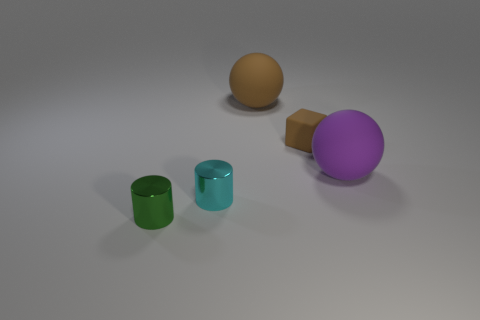How many cyan cylinders are the same size as the green metallic cylinder?
Your answer should be compact. 1. There is a thing that is the same color as the rubber block; what is its shape?
Give a very brief answer. Sphere. Do the metal cylinder behind the tiny green metal thing and the rubber object that is right of the small matte cube have the same color?
Offer a very short reply. No. What number of brown things are right of the large brown rubber ball?
Ensure brevity in your answer.  1. Are there any small cyan shiny objects that have the same shape as the small green metallic object?
Make the answer very short. Yes. What color is the rubber cube that is the same size as the cyan cylinder?
Offer a terse response. Brown. Is the number of large purple things in front of the green cylinder less than the number of spheres right of the large brown rubber object?
Your response must be concise. Yes. Is the size of the metal object that is on the right side of the green metal cylinder the same as the tiny rubber thing?
Ensure brevity in your answer.  Yes. There is a small shiny thing to the left of the small cyan metallic thing; what shape is it?
Keep it short and to the point. Cylinder. Are there more big red metal cylinders than green metal objects?
Your answer should be compact. No. 